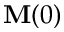Convert formula to latex. <formula><loc_0><loc_0><loc_500><loc_500>\mathbf M ( 0 )</formula> 